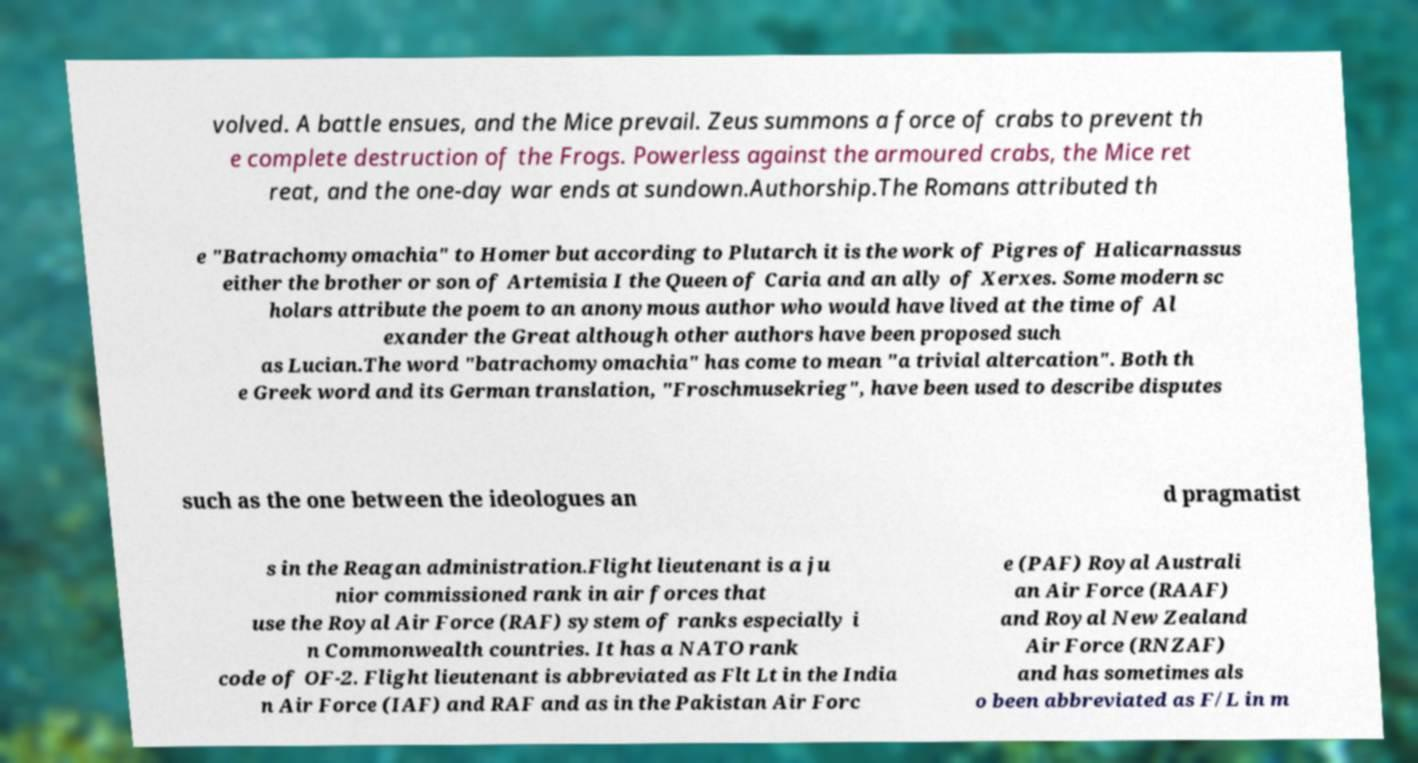Can you read and provide the text displayed in the image?This photo seems to have some interesting text. Can you extract and type it out for me? volved. A battle ensues, and the Mice prevail. Zeus summons a force of crabs to prevent th e complete destruction of the Frogs. Powerless against the armoured crabs, the Mice ret reat, and the one-day war ends at sundown.Authorship.The Romans attributed th e "Batrachomyomachia" to Homer but according to Plutarch it is the work of Pigres of Halicarnassus either the brother or son of Artemisia I the Queen of Caria and an ally of Xerxes. Some modern sc holars attribute the poem to an anonymous author who would have lived at the time of Al exander the Great although other authors have been proposed such as Lucian.The word "batrachomyomachia" has come to mean "a trivial altercation". Both th e Greek word and its German translation, "Froschmusekrieg", have been used to describe disputes such as the one between the ideologues an d pragmatist s in the Reagan administration.Flight lieutenant is a ju nior commissioned rank in air forces that use the Royal Air Force (RAF) system of ranks especially i n Commonwealth countries. It has a NATO rank code of OF-2. Flight lieutenant is abbreviated as Flt Lt in the India n Air Force (IAF) and RAF and as in the Pakistan Air Forc e (PAF) Royal Australi an Air Force (RAAF) and Royal New Zealand Air Force (RNZAF) and has sometimes als o been abbreviated as F/L in m 